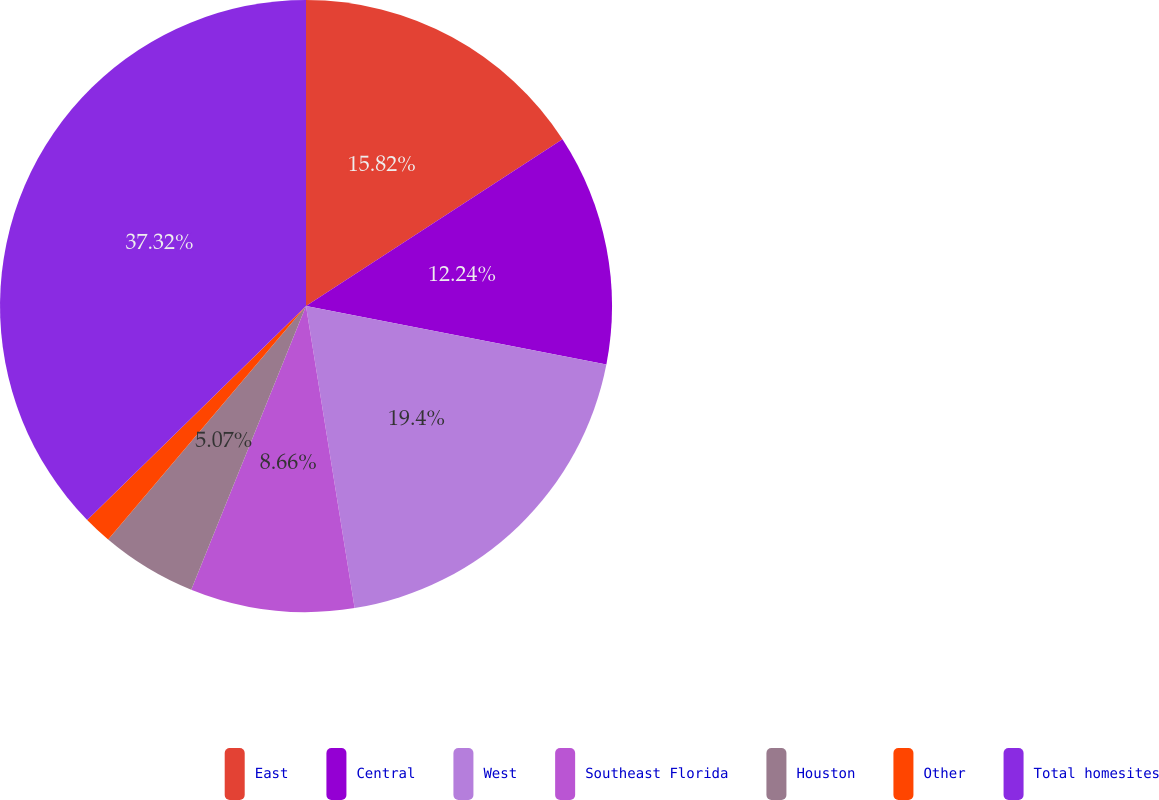Convert chart to OTSL. <chart><loc_0><loc_0><loc_500><loc_500><pie_chart><fcel>East<fcel>Central<fcel>West<fcel>Southeast Florida<fcel>Houston<fcel>Other<fcel>Total homesites<nl><fcel>15.82%<fcel>12.24%<fcel>19.4%<fcel>8.66%<fcel>5.07%<fcel>1.49%<fcel>37.32%<nl></chart> 